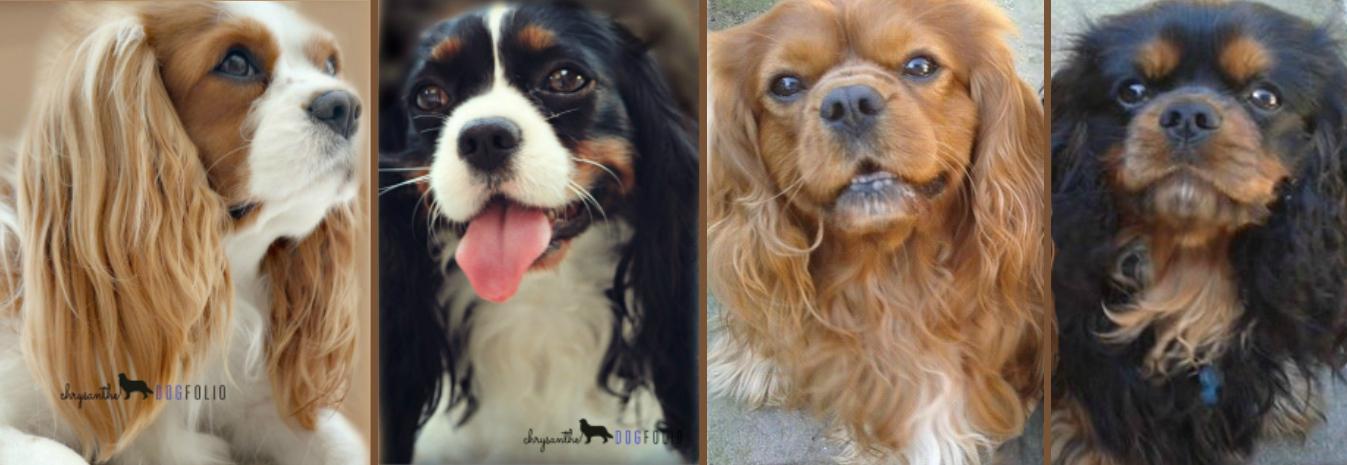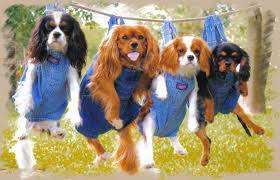The first image is the image on the left, the second image is the image on the right. For the images shown, is this caption "Four dogs are outside together." true? Answer yes or no. Yes. The first image is the image on the left, the second image is the image on the right. For the images shown, is this caption "Each image is a full body shot of four different dogs." true? Answer yes or no. No. 